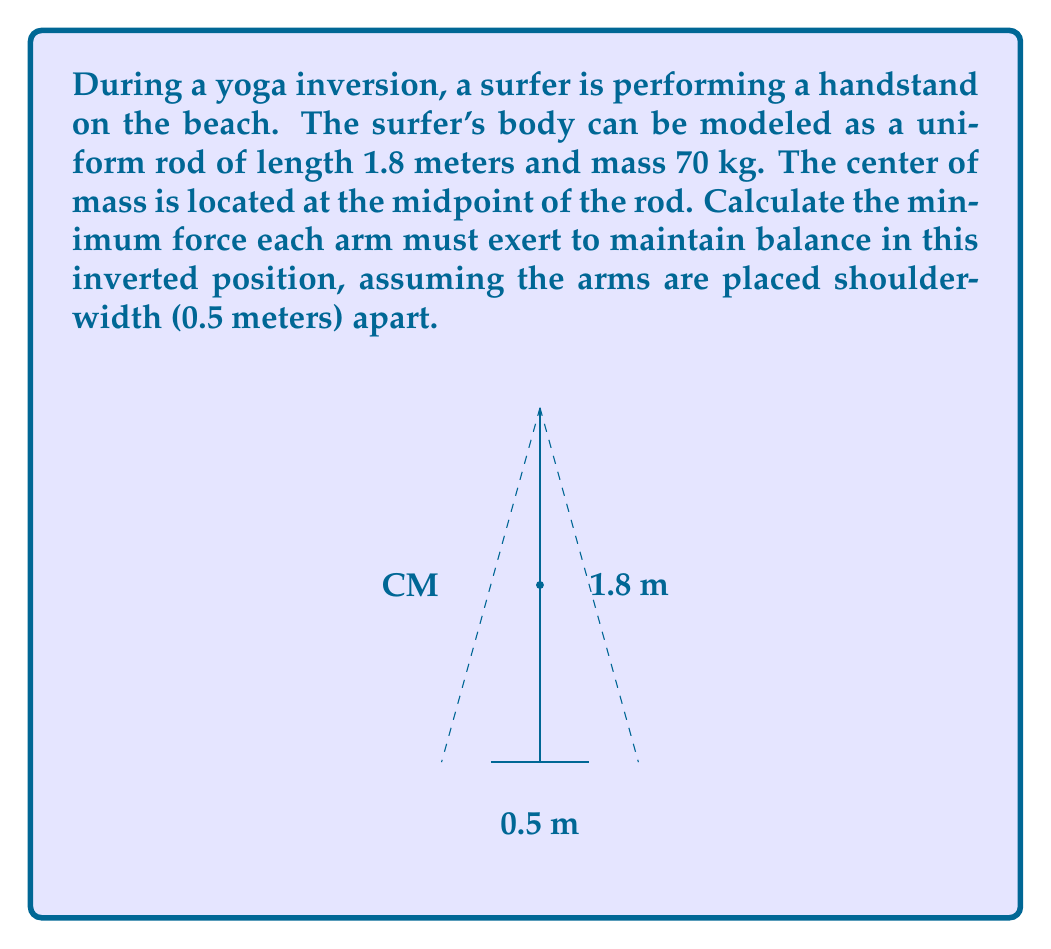Provide a solution to this math problem. To solve this problem, we'll use principles of static equilibrium and moments. Let's break it down step-by-step:

1) First, we need to calculate the weight of the surfer:
   $W = mg = 70 \text{ kg} \times 9.8 \text{ m/s}^2 = 686 \text{ N}$

2) The weight acts at the center of mass, which is at the midpoint of the rod (0.9 m from either end).

3) For static equilibrium, the sum of forces and the sum of moments must both be zero.

4) Let $F$ be the force exerted by each arm. The sum of vertical forces must be zero:
   $2F - W = 0$
   $2F = 686 \text{ N}$
   $F = 343 \text{ N}$

5) Now, let's check the moments around one of the hands:
   Moment due to weight: $W \times 0.25 \text{ m} = 686 \text{ N} \times 0.25 \text{ m} = 171.5 \text{ Nm}$
   Moment due to other hand: $F \times 0.5 \text{ m} = 343 \text{ N} \times 0.5 \text{ m} = 171.5 \text{ Nm}$

6) The moments balance, confirming our calculation.

Therefore, each arm must exert a force of 343 N upward to maintain balance in this inverted position.
Answer: $343 \text{ N}$ 